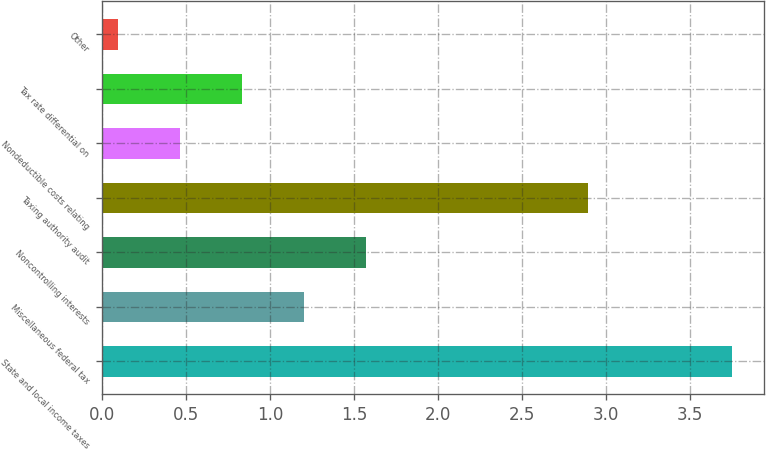Convert chart. <chart><loc_0><loc_0><loc_500><loc_500><bar_chart><fcel>State and local income taxes<fcel>Miscellaneous federal tax<fcel>Noncontrolling interests<fcel>Taxing authority audit<fcel>Nondeductible costs relating<fcel>Tax rate differential on<fcel>Other<nl><fcel>3.75<fcel>1.2<fcel>1.57<fcel>2.89<fcel>0.46<fcel>0.83<fcel>0.09<nl></chart> 